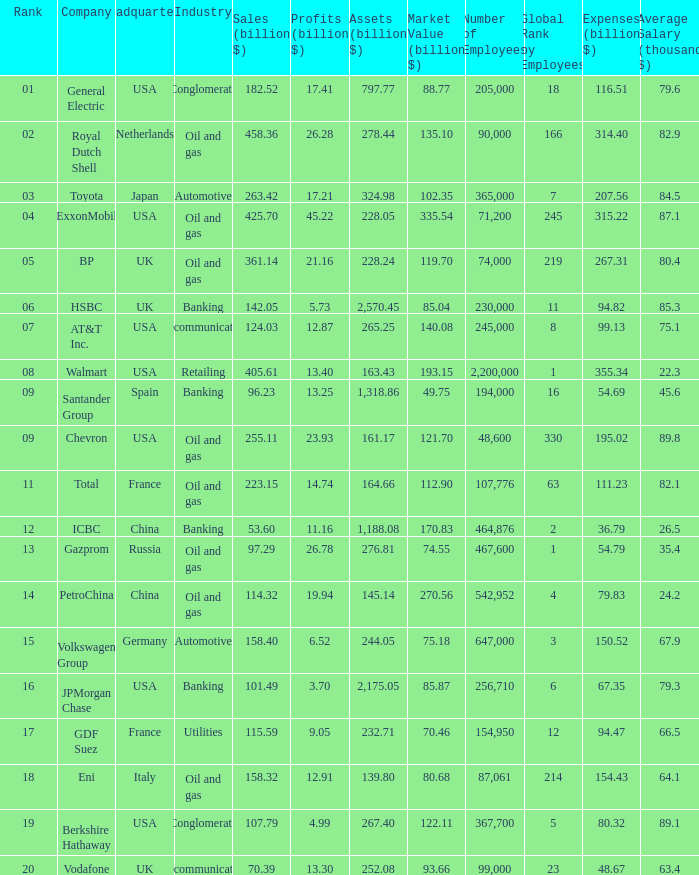Name the lowest Market Value (billion $) which has Assets (billion $) larger than 276.81, and a Company of toyota, and Profits (billion $) larger than 17.21? None. 